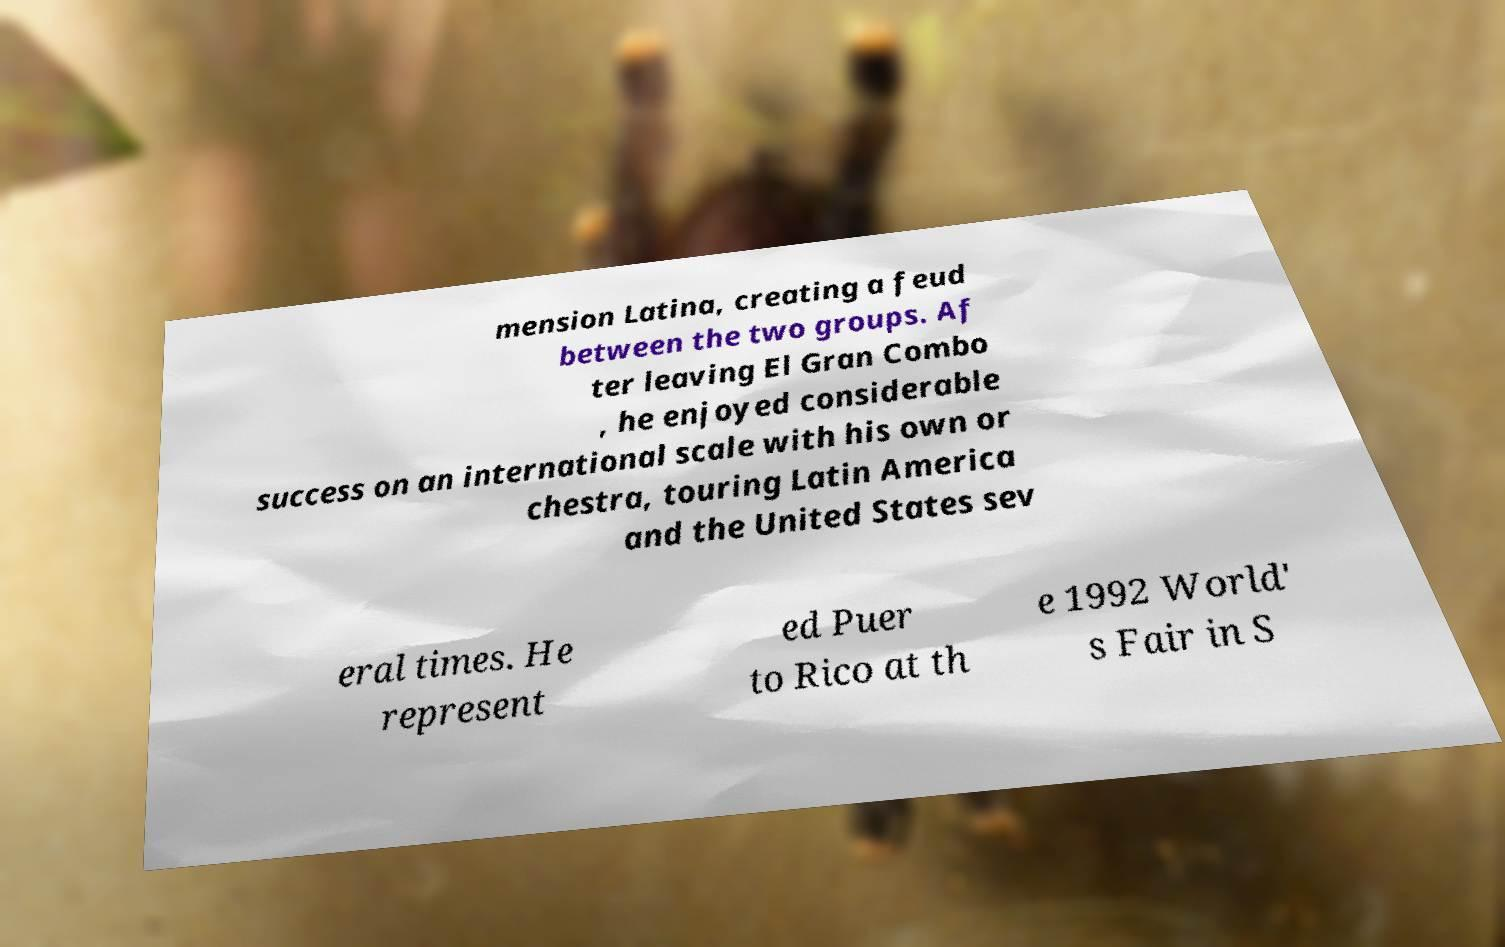Please read and relay the text visible in this image. What does it say? mension Latina, creating a feud between the two groups. Af ter leaving El Gran Combo , he enjoyed considerable success on an international scale with his own or chestra, touring Latin America and the United States sev eral times. He represent ed Puer to Rico at th e 1992 World' s Fair in S 